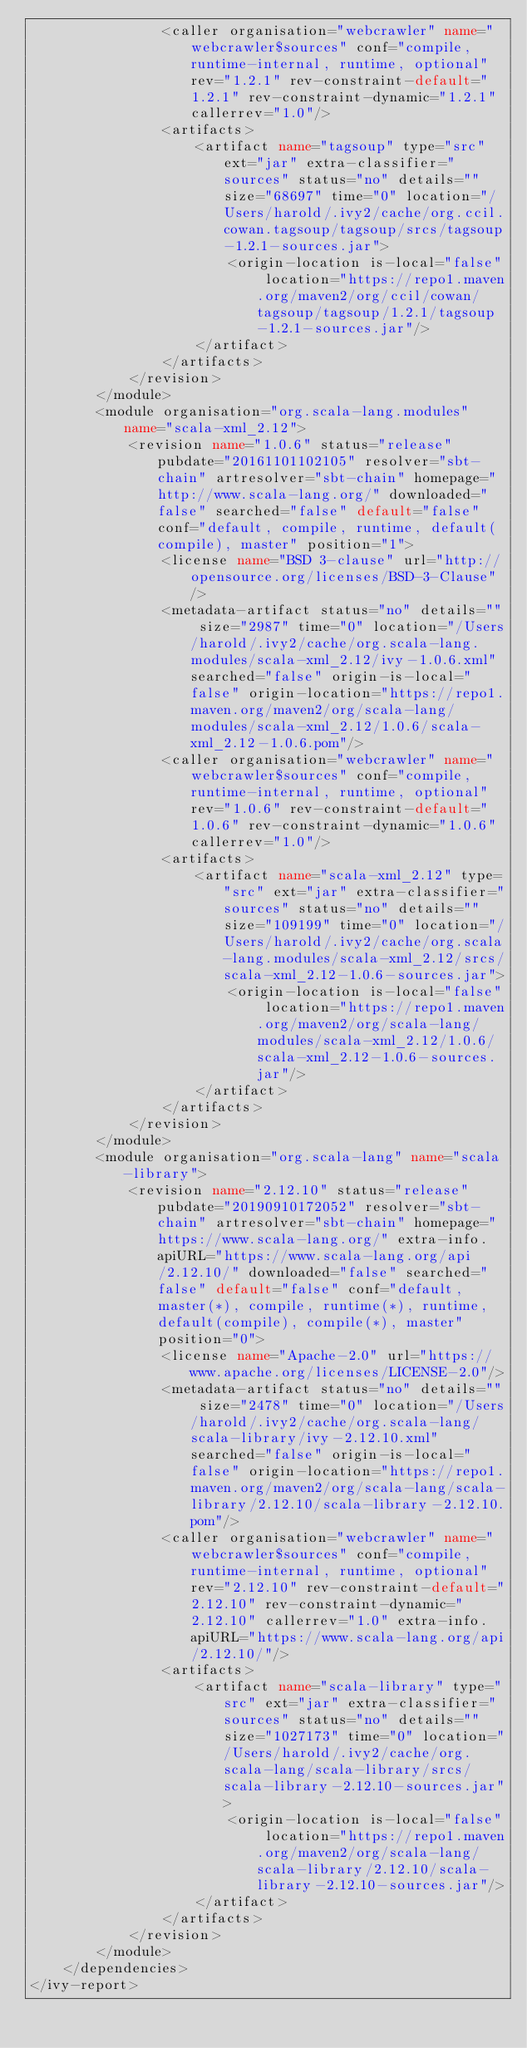<code> <loc_0><loc_0><loc_500><loc_500><_XML_>				<caller organisation="webcrawler" name="webcrawler$sources" conf="compile, runtime-internal, runtime, optional" rev="1.2.1" rev-constraint-default="1.2.1" rev-constraint-dynamic="1.2.1" callerrev="1.0"/>
				<artifacts>
					<artifact name="tagsoup" type="src" ext="jar" extra-classifier="sources" status="no" details="" size="68697" time="0" location="/Users/harold/.ivy2/cache/org.ccil.cowan.tagsoup/tagsoup/srcs/tagsoup-1.2.1-sources.jar">
						<origin-location is-local="false" location="https://repo1.maven.org/maven2/org/ccil/cowan/tagsoup/tagsoup/1.2.1/tagsoup-1.2.1-sources.jar"/>
					</artifact>
				</artifacts>
			</revision>
		</module>
		<module organisation="org.scala-lang.modules" name="scala-xml_2.12">
			<revision name="1.0.6" status="release" pubdate="20161101102105" resolver="sbt-chain" artresolver="sbt-chain" homepage="http://www.scala-lang.org/" downloaded="false" searched="false" default="false" conf="default, compile, runtime, default(compile), master" position="1">
				<license name="BSD 3-clause" url="http://opensource.org/licenses/BSD-3-Clause"/>
				<metadata-artifact status="no" details="" size="2987" time="0" location="/Users/harold/.ivy2/cache/org.scala-lang.modules/scala-xml_2.12/ivy-1.0.6.xml" searched="false" origin-is-local="false" origin-location="https://repo1.maven.org/maven2/org/scala-lang/modules/scala-xml_2.12/1.0.6/scala-xml_2.12-1.0.6.pom"/>
				<caller organisation="webcrawler" name="webcrawler$sources" conf="compile, runtime-internal, runtime, optional" rev="1.0.6" rev-constraint-default="1.0.6" rev-constraint-dynamic="1.0.6" callerrev="1.0"/>
				<artifacts>
					<artifact name="scala-xml_2.12" type="src" ext="jar" extra-classifier="sources" status="no" details="" size="109199" time="0" location="/Users/harold/.ivy2/cache/org.scala-lang.modules/scala-xml_2.12/srcs/scala-xml_2.12-1.0.6-sources.jar">
						<origin-location is-local="false" location="https://repo1.maven.org/maven2/org/scala-lang/modules/scala-xml_2.12/1.0.6/scala-xml_2.12-1.0.6-sources.jar"/>
					</artifact>
				</artifacts>
			</revision>
		</module>
		<module organisation="org.scala-lang" name="scala-library">
			<revision name="2.12.10" status="release" pubdate="20190910172052" resolver="sbt-chain" artresolver="sbt-chain" homepage="https://www.scala-lang.org/" extra-info.apiURL="https://www.scala-lang.org/api/2.12.10/" downloaded="false" searched="false" default="false" conf="default, master(*), compile, runtime(*), runtime, default(compile), compile(*), master" position="0">
				<license name="Apache-2.0" url="https://www.apache.org/licenses/LICENSE-2.0"/>
				<metadata-artifact status="no" details="" size="2478" time="0" location="/Users/harold/.ivy2/cache/org.scala-lang/scala-library/ivy-2.12.10.xml" searched="false" origin-is-local="false" origin-location="https://repo1.maven.org/maven2/org/scala-lang/scala-library/2.12.10/scala-library-2.12.10.pom"/>
				<caller organisation="webcrawler" name="webcrawler$sources" conf="compile, runtime-internal, runtime, optional" rev="2.12.10" rev-constraint-default="2.12.10" rev-constraint-dynamic="2.12.10" callerrev="1.0" extra-info.apiURL="https://www.scala-lang.org/api/2.12.10/"/>
				<artifacts>
					<artifact name="scala-library" type="src" ext="jar" extra-classifier="sources" status="no" details="" size="1027173" time="0" location="/Users/harold/.ivy2/cache/org.scala-lang/scala-library/srcs/scala-library-2.12.10-sources.jar">
						<origin-location is-local="false" location="https://repo1.maven.org/maven2/org/scala-lang/scala-library/2.12.10/scala-library-2.12.10-sources.jar"/>
					</artifact>
				</artifacts>
			</revision>
		</module>
	</dependencies>
</ivy-report>
</code> 